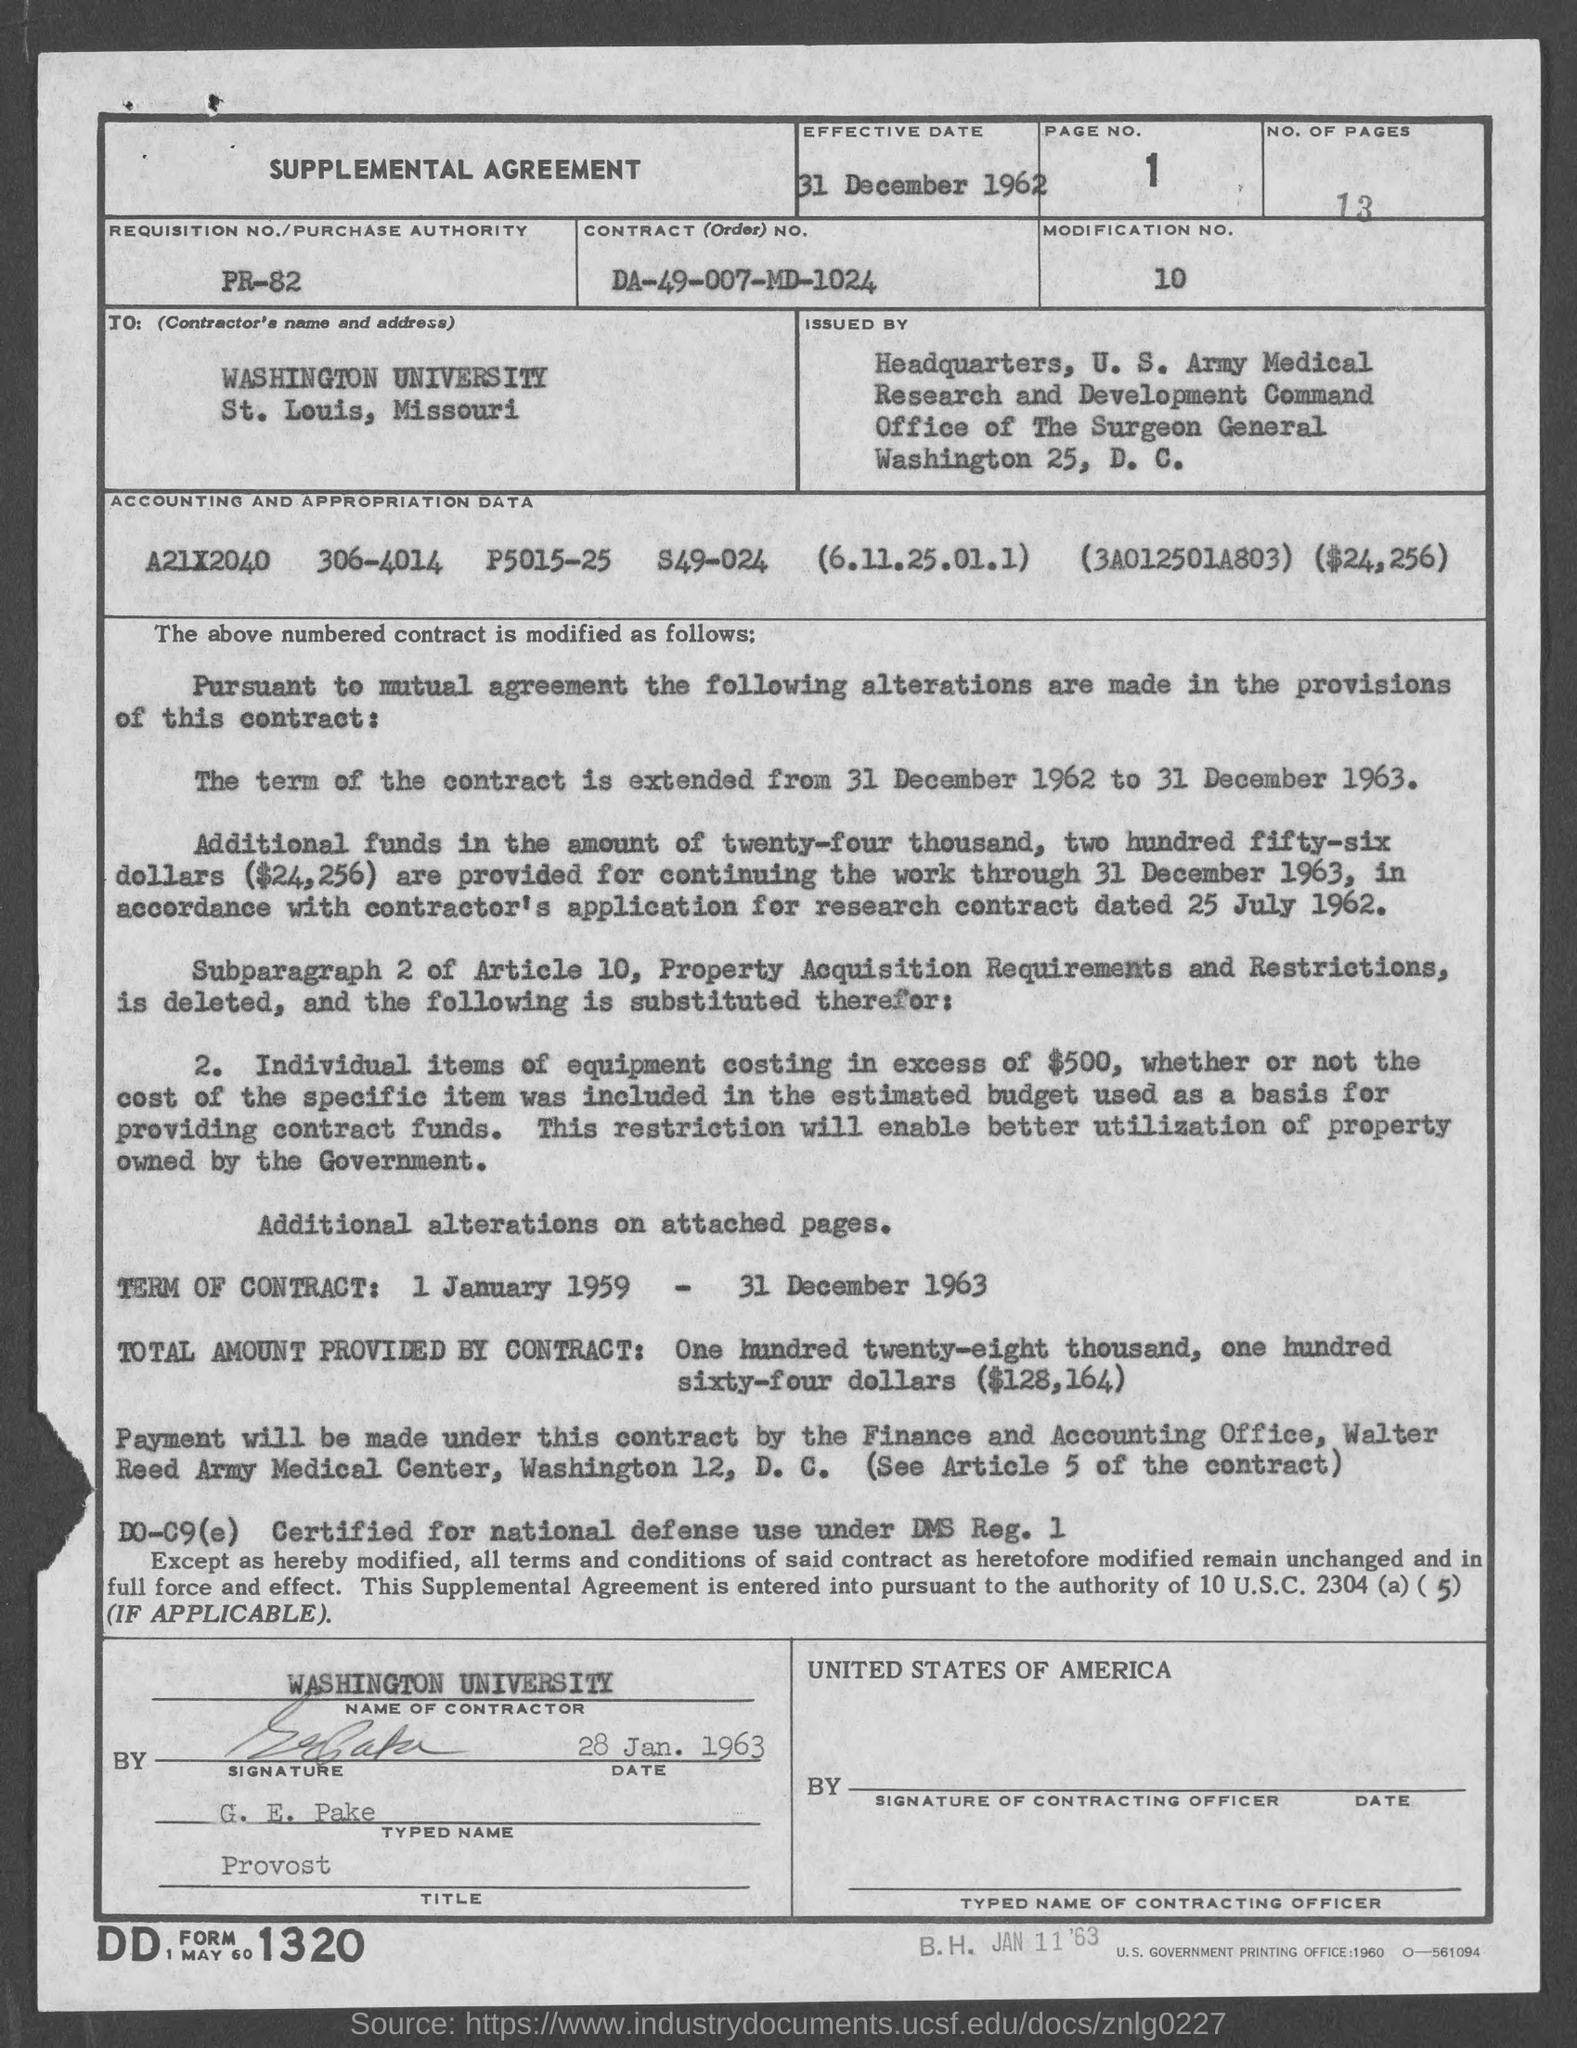Indicate a few pertinent items in this graphic. The term of the contract is from 1 January 1959 to 31 December 1963. In this document, page number 1 is the first page. This is a supplemental agreement. The effective date of 31 December 1962 has been established. There are 13 pages mentioned. 